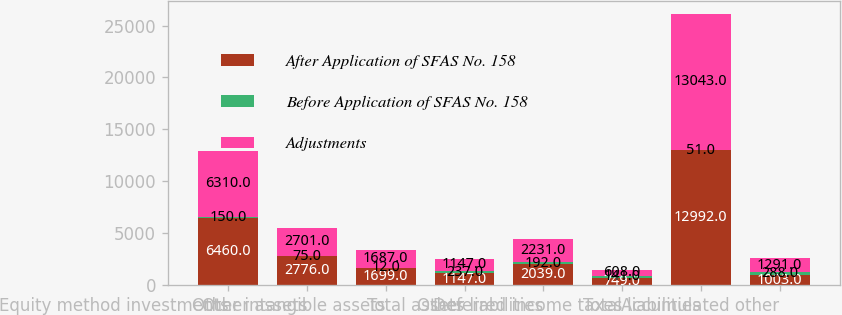Convert chart. <chart><loc_0><loc_0><loc_500><loc_500><stacked_bar_chart><ecel><fcel>Equity method investments<fcel>Other assets<fcel>Other intangible assets<fcel>Total assets<fcel>Other liabilities<fcel>Deferred income taxes<fcel>Total liabilities<fcel>Accumulated other<nl><fcel>After Application of SFAS No. 158<fcel>6460<fcel>2776<fcel>1699<fcel>1147<fcel>2039<fcel>749<fcel>12992<fcel>1003<nl><fcel>Before Application of SFAS No. 158<fcel>150<fcel>75<fcel>12<fcel>237<fcel>192<fcel>141<fcel>51<fcel>288<nl><fcel>Adjustments<fcel>6310<fcel>2701<fcel>1687<fcel>1147<fcel>2231<fcel>608<fcel>13043<fcel>1291<nl></chart> 